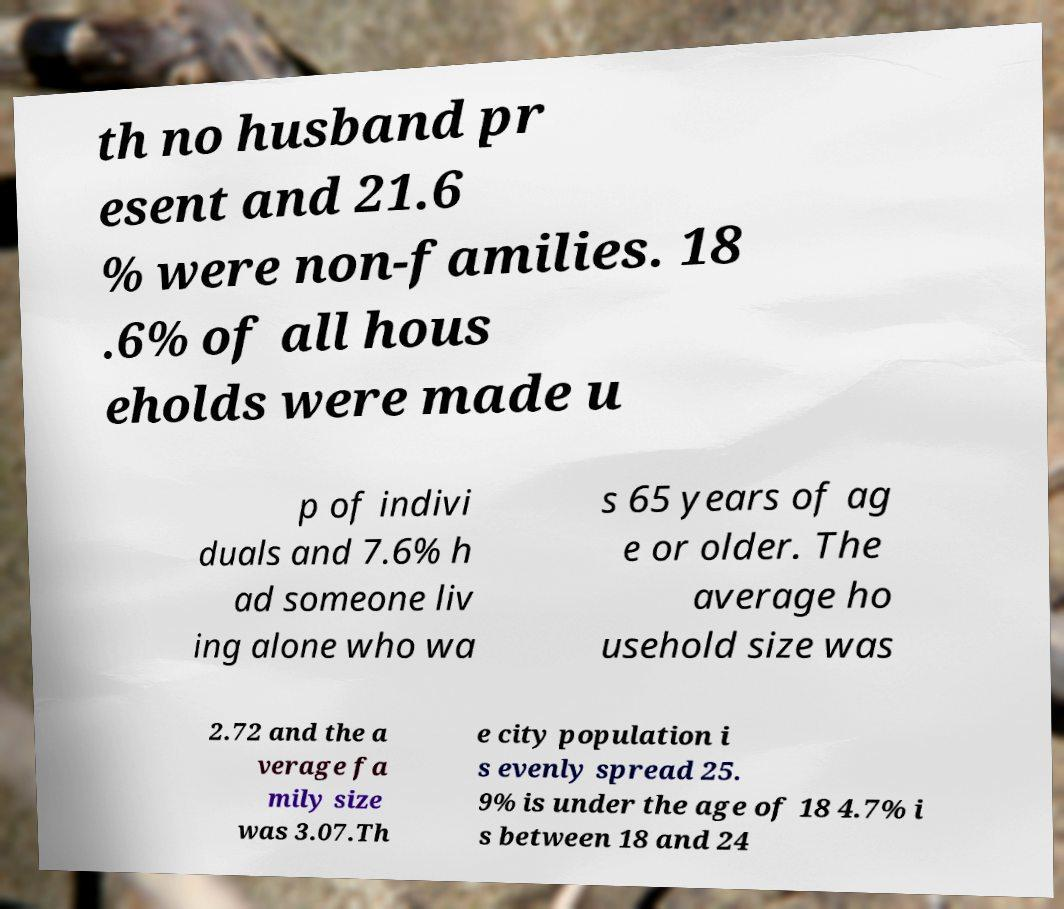Could you assist in decoding the text presented in this image and type it out clearly? th no husband pr esent and 21.6 % were non-families. 18 .6% of all hous eholds were made u p of indivi duals and 7.6% h ad someone liv ing alone who wa s 65 years of ag e or older. The average ho usehold size was 2.72 and the a verage fa mily size was 3.07.Th e city population i s evenly spread 25. 9% is under the age of 18 4.7% i s between 18 and 24 